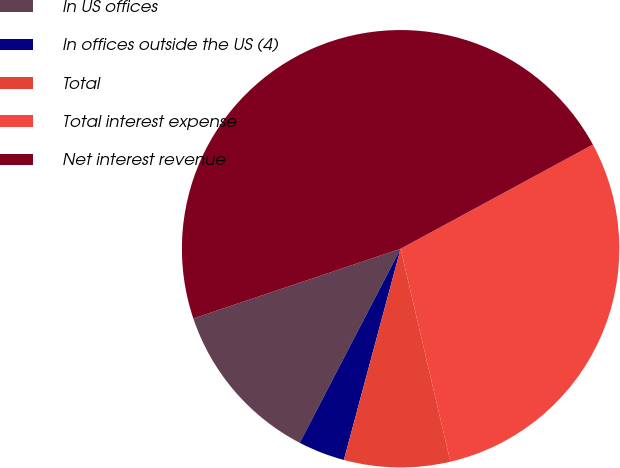<chart> <loc_0><loc_0><loc_500><loc_500><pie_chart><fcel>In US offices<fcel>In offices outside the US (4)<fcel>Total<fcel>Total interest expense<fcel>Net interest revenue<nl><fcel>12.21%<fcel>3.45%<fcel>7.83%<fcel>29.25%<fcel>47.27%<nl></chart> 